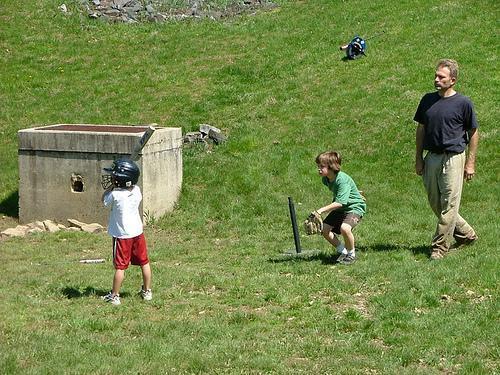How many children are in the photo?
Give a very brief answer. 2. How many people are in the photo?
Give a very brief answer. 3. 